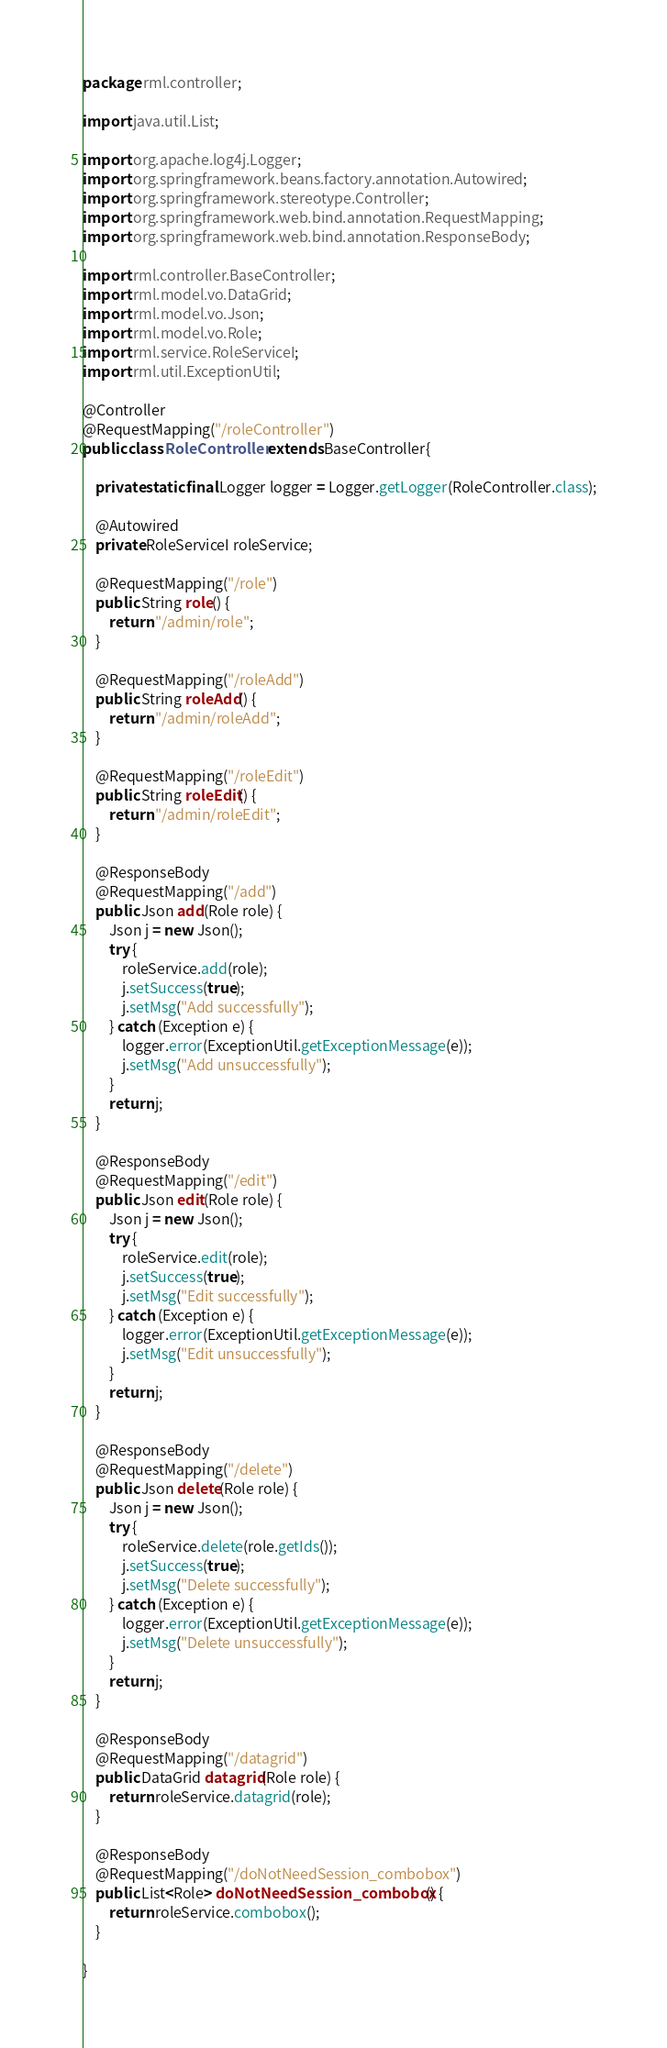Convert code to text. <code><loc_0><loc_0><loc_500><loc_500><_Java_>package rml.controller;

import java.util.List;

import org.apache.log4j.Logger;
import org.springframework.beans.factory.annotation.Autowired;
import org.springframework.stereotype.Controller;
import org.springframework.web.bind.annotation.RequestMapping;
import org.springframework.web.bind.annotation.ResponseBody;

import rml.controller.BaseController;
import rml.model.vo.DataGrid;
import rml.model.vo.Json;
import rml.model.vo.Role;
import rml.service.RoleServiceI;
import rml.util.ExceptionUtil;

@Controller
@RequestMapping("/roleController")
public class RoleController extends BaseController{

	private static final Logger logger = Logger.getLogger(RoleController.class);
	
	@Autowired
	private RoleServiceI roleService;

	@RequestMapping("/role")
	public String role() {
		return "/admin/role";
	}

	@RequestMapping("/roleAdd")
	public String roleAdd() {
		return "/admin/roleAdd";
	}

	@RequestMapping("/roleEdit")
	public String roleEdit() {
		return "/admin/roleEdit";
	}
	
	@ResponseBody
	@RequestMapping("/add")
	public Json add(Role role) {
		Json j = new Json();
		try {
			roleService.add(role);
			j.setSuccess(true);
			j.setMsg("Add successfully");
		} catch (Exception e) {
			logger.error(ExceptionUtil.getExceptionMessage(e));
			j.setMsg("Add unsuccessfully");
		}
		return j;
	}

	@ResponseBody
	@RequestMapping("/edit")
	public Json edit(Role role) {
		Json j = new Json();
		try {
			roleService.edit(role);
			j.setSuccess(true);
			j.setMsg("Edit successfully");
		} catch (Exception e) {
			logger.error(ExceptionUtil.getExceptionMessage(e));
			j.setMsg("Edit unsuccessfully");
		}
		return j;
	}

	@ResponseBody
	@RequestMapping("/delete")
	public Json delete(Role role) {
		Json j = new Json();
		try {
			roleService.delete(role.getIds());
			j.setSuccess(true);
			j.setMsg("Delete successfully");
		} catch (Exception e) {
			logger.error(ExceptionUtil.getExceptionMessage(e));
			j.setMsg("Delete unsuccessfully");
		}
		return j;
	}

	@ResponseBody
	@RequestMapping("/datagrid")
	public DataGrid datagrid(Role role) {
		return roleService.datagrid(role);
	}
	
	@ResponseBody
	@RequestMapping("/doNotNeedSession_combobox")
	public List<Role> doNotNeedSession_combobox() {
		return roleService.combobox();
	}

}
</code> 